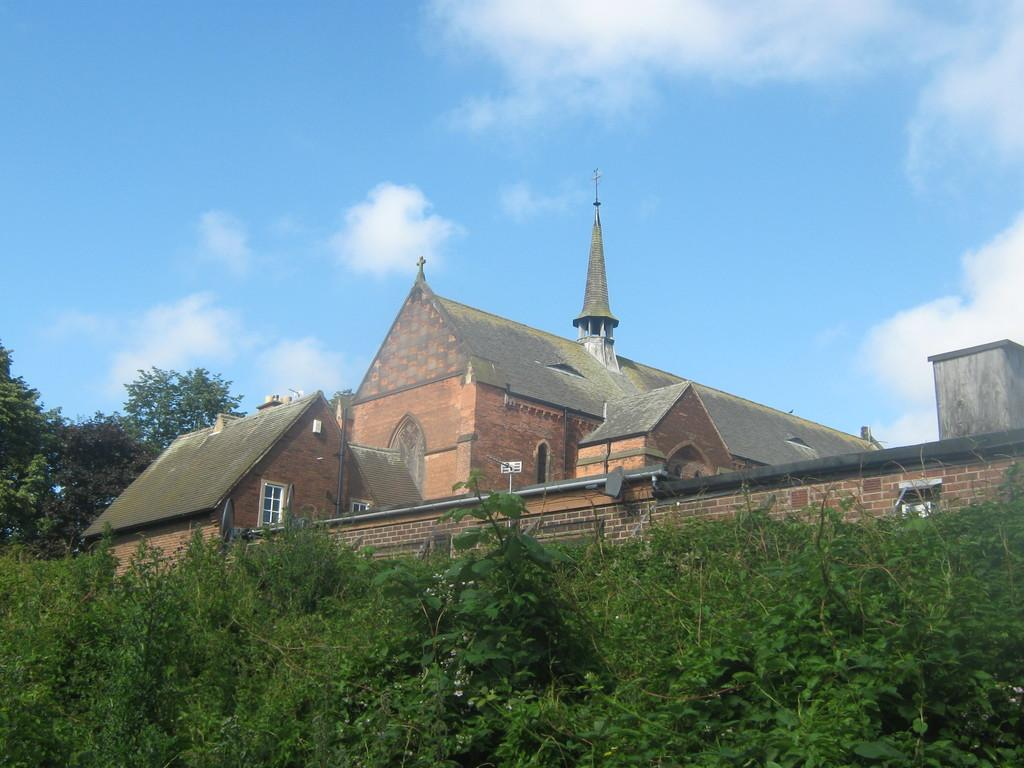What type of structure is present in the image? There is a building in the image. What feature can be seen on the building? There is a cross on the building. What type of vegetation is at the bottom of the image? There are plants at the bottom of the image. What type of vegetation is on the left side of the image? There are trees to the left of the image. What is visible at the top of the image? The sky is visible at the top of the image. What type of rock is being used as a doorstop in the image? There is no rock or doorstop visible in the image. 